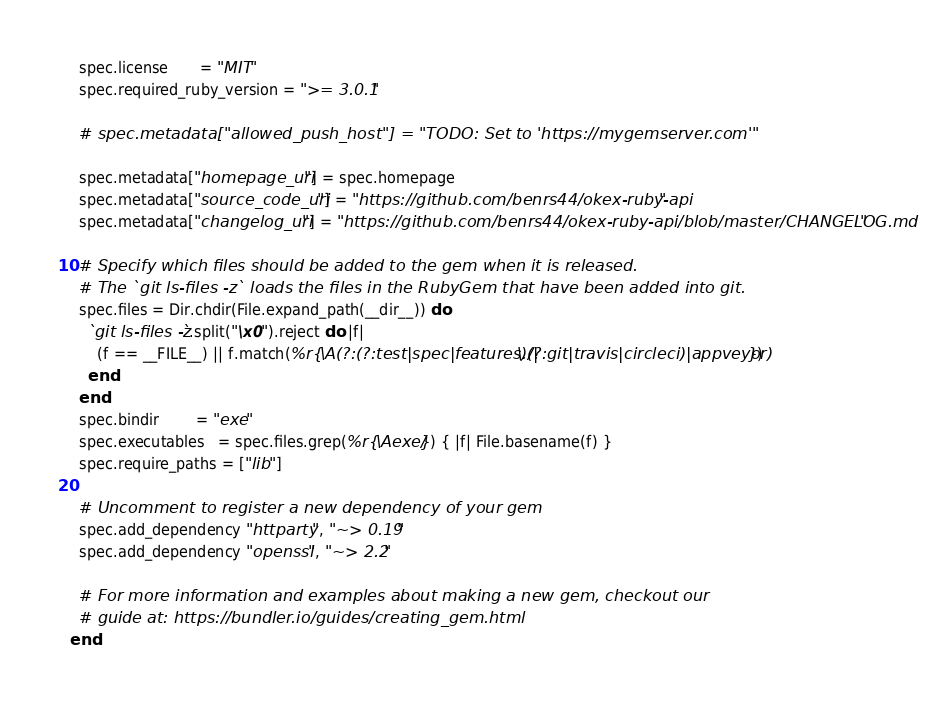<code> <loc_0><loc_0><loc_500><loc_500><_Ruby_>  spec.license       = "MIT"
  spec.required_ruby_version = ">= 3.0.1"

  # spec.metadata["allowed_push_host"] = "TODO: Set to 'https://mygemserver.com'"

  spec.metadata["homepage_uri"] = spec.homepage
  spec.metadata["source_code_uri"] = "https://github.com/benrs44/okex-ruby-api"
  spec.metadata["changelog_uri"] = "https://github.com/benrs44/okex-ruby-api/blob/master/CHANGELOG.md"

  # Specify which files should be added to the gem when it is released.
  # The `git ls-files -z` loads the files in the RubyGem that have been added into git.
  spec.files = Dir.chdir(File.expand_path(__dir__)) do
    `git ls-files -z`.split("\x0").reject do |f|
      (f == __FILE__) || f.match(%r{\A(?:(?:test|spec|features)/|\.(?:git|travis|circleci)|appveyor)})
    end
  end
  spec.bindir        = "exe"
  spec.executables   = spec.files.grep(%r{\Aexe/}) { |f| File.basename(f) }
  spec.require_paths = ["lib"]

  # Uncomment to register a new dependency of your gem
  spec.add_dependency "httparty", "~> 0.19"
  spec.add_dependency "openssl", "~> 2.2"

  # For more information and examples about making a new gem, checkout our
  # guide at: https://bundler.io/guides/creating_gem.html
end
</code> 